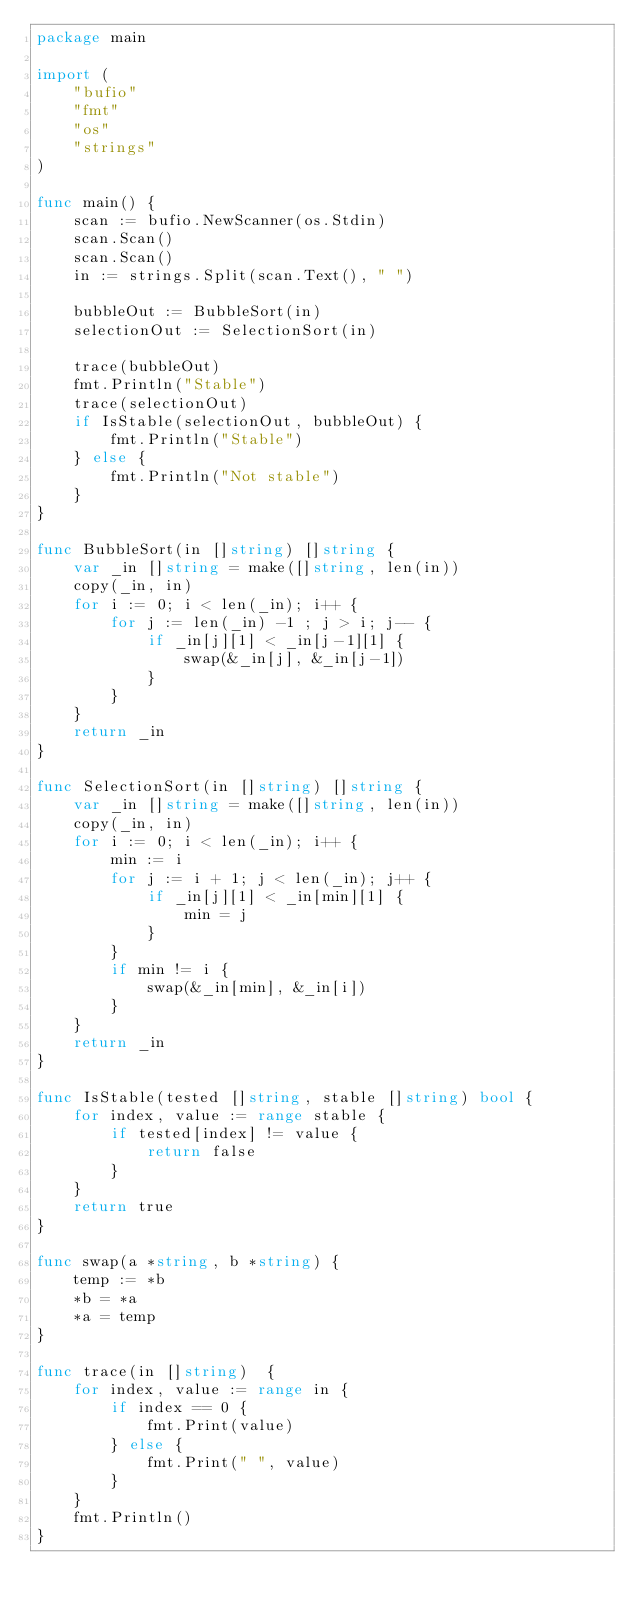Convert code to text. <code><loc_0><loc_0><loc_500><loc_500><_Go_>package main

import (
	"bufio"
	"fmt"
	"os"
	"strings"
)

func main() {
	scan := bufio.NewScanner(os.Stdin)
	scan.Scan()
	scan.Scan()
	in := strings.Split(scan.Text(), " ")

	bubbleOut := BubbleSort(in)
	selectionOut := SelectionSort(in)

	trace(bubbleOut)
	fmt.Println("Stable")
	trace(selectionOut)
	if IsStable(selectionOut, bubbleOut) {
		fmt.Println("Stable")
	} else {
		fmt.Println("Not stable")
	}
}

func BubbleSort(in []string) []string {
	var _in []string = make([]string, len(in))
	copy(_in, in)
	for i := 0; i < len(_in); i++ {
		for j := len(_in) -1 ; j > i; j-- {
			if _in[j][1] < _in[j-1][1] {
				swap(&_in[j], &_in[j-1])
			}
		}
	}
	return _in
}

func SelectionSort(in []string) []string {
	var _in []string = make([]string, len(in))
	copy(_in, in)
	for i := 0; i < len(_in); i++ {
		min := i
		for j := i + 1; j < len(_in); j++ {
			if _in[j][1] < _in[min][1] {
				min = j
			}
		}
		if min != i {
			swap(&_in[min], &_in[i])
		}
	}
	return _in
}

func IsStable(tested []string, stable []string) bool {
	for index, value := range stable {
		if tested[index] != value {
			return false
		}
	}
	return true
}

func swap(a *string, b *string) {
	temp := *b
	*b = *a
	*a = temp
}

func trace(in []string)  {
	for index, value := range in {
		if index == 0 {
			fmt.Print(value)
		} else {
			fmt.Print(" ", value)
		}
	}
	fmt.Println()
}
</code> 